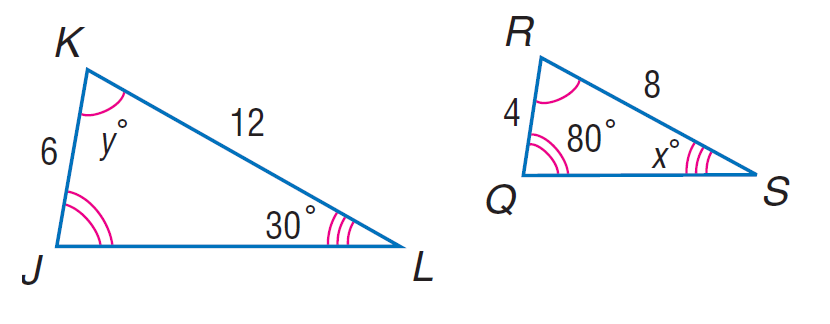Answer the mathemtical geometry problem and directly provide the correct option letter.
Question: Each pair of polygons is similar. Find x.
Choices: A: 30 B: 70 C: 80 D: 150 A 